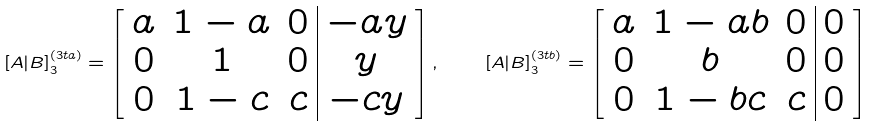Convert formula to latex. <formula><loc_0><loc_0><loc_500><loc_500>[ A | B ] _ { 3 } ^ { ( 3 t a ) } = \left [ \begin{array} { c c c | c } a & 1 - a & 0 & - a y \\ 0 & 1 & 0 & y \\ 0 & 1 - c & c & - c y \end{array} \right ] , \quad [ A | B ] _ { 3 } ^ { ( 3 t b ) } = \left [ \begin{array} { c c c | c } a & 1 - a b & 0 & 0 \\ 0 & b & 0 & 0 \\ 0 & 1 - b c & c & 0 \end{array} \right ]</formula> 